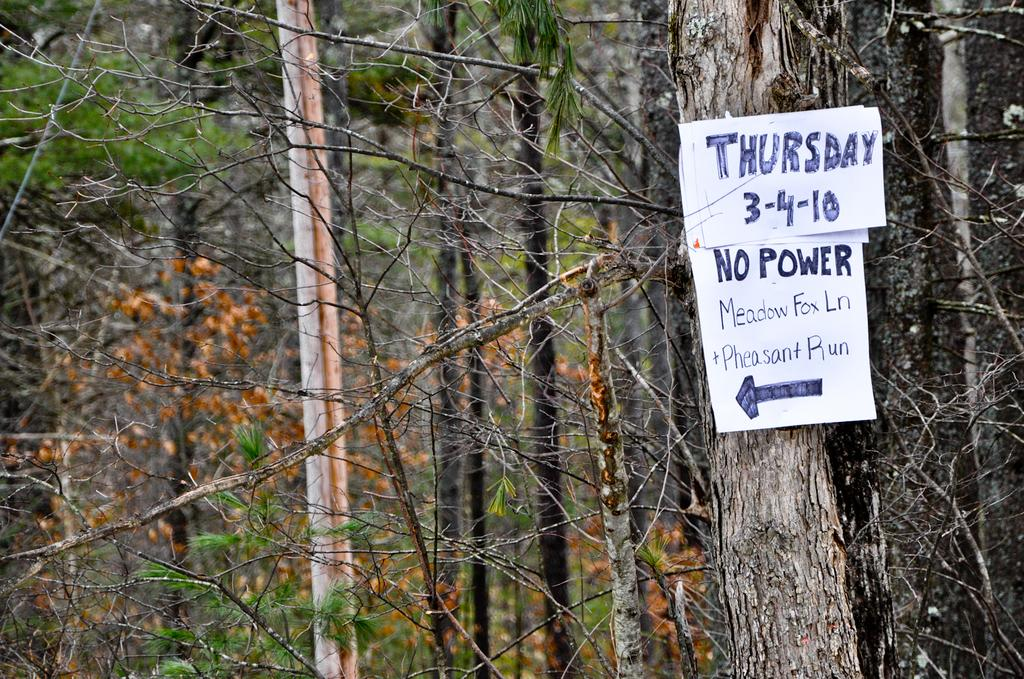What is located on the trunk in the foreground of the image? There are posters on a trunk in the foreground of the image. On which side of the image are the posters located? The posters are on the right side of the image. What can be seen in the background of the image? There are trees in the background of the image. What type of bean is being served for dinner in the image? There is no dinner or bean present in the image. How many pins are visible on the posters in the image? There is no mention of pins on the posters in the provided facts, so we cannot determine their presence or quantity. 